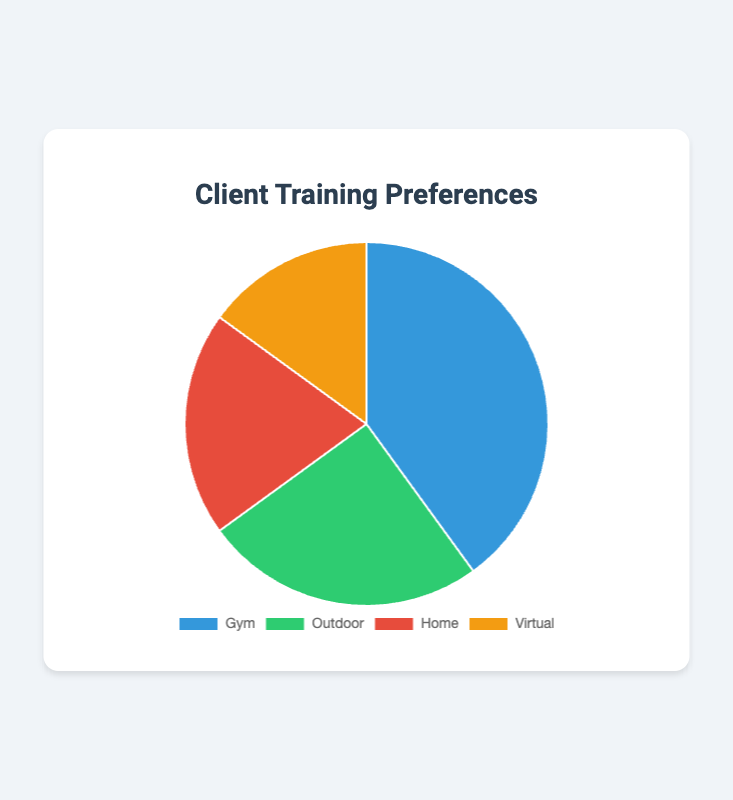What are the percentages of clients who prefer to train at home and outdoor combined? To find the combined percentage of clients who prefer home and outdoor settings, you need to add the percentages of these two settings together: 20% (Home) + 25% (Outdoor) = 45%.
Answer: 45% Which training setting is the most preferred by clients? By looking at the pie chart, the segment with the largest percentage will indicate the most preferred training setting. The Gym setting has the largest percentage at 40%.
Answer: Gym How does the percentage of clients preferring virtual training compare to those preferring gym training? To compare, subtract the percentage of clients who prefer virtual training (15%) from those who prefer gym training (40%): 40% - 15% = 25%. Gym training is preferred by 25% more clients.
Answer: 25% more for Gym What is the difference in preference percentages between home and outdoor training settings? Subtract the percentage of clients who prefer home training (20%) from those who prefer outdoor training (25%): 25% - 20% = 5%.
Answer: 5% Which training setting has the smallest preference percentage and by how much is it the lowest compared to the one with the highest? Virtual training has the smallest preference percentage at 15%. The highest is Gym at 40%. The difference is 40% - 15% = 25%.
Answer: Virtual, 25% What is the average percentage preference for all four training settings? To find the average, add all the preference percentages together and divide by the number of settings: (40% + 25% + 20% + 15%) / 4 = 100% / 4 = 25%.
Answer: 25% If a client chooses three training settings randomly, what is the probability that none of the chosen settings is Virtual? Calculate probabilities individually for Gym, Outdoor, and Home, then add them: 40% (Gym) + 25% (Outdoor) + 20% (Home) = 85%. So the probability that none is Virtual is 85%.
Answer: 85% What percentage of clients preferred training settings other than Gym? To find this, add the percentages of clients preferring all non-Gym settings: Outdoor (25%), Home (20%), and Virtual (15%): 25% + 20% + 15% = 60%.
Answer: 60% Is the total percentage of clients preferring home and virtual training higher or lower than those preferring gym training? Add the percentages of clients preferring home (20%) and virtual (15%) training: 20% + 15% = 35%, and compare it to Gym (40%). 35% is lower than 40%.
Answer: Lower What are the colors representing each of the training settings, and which setting corresponds to the green segment? By identifying the visual attributes of the pie chart, we see that Outdoor is the segment colored green. The other colors are blue (Gym), red (Home), and yellow (Virtual).
Answer: Green represents Outdoor 